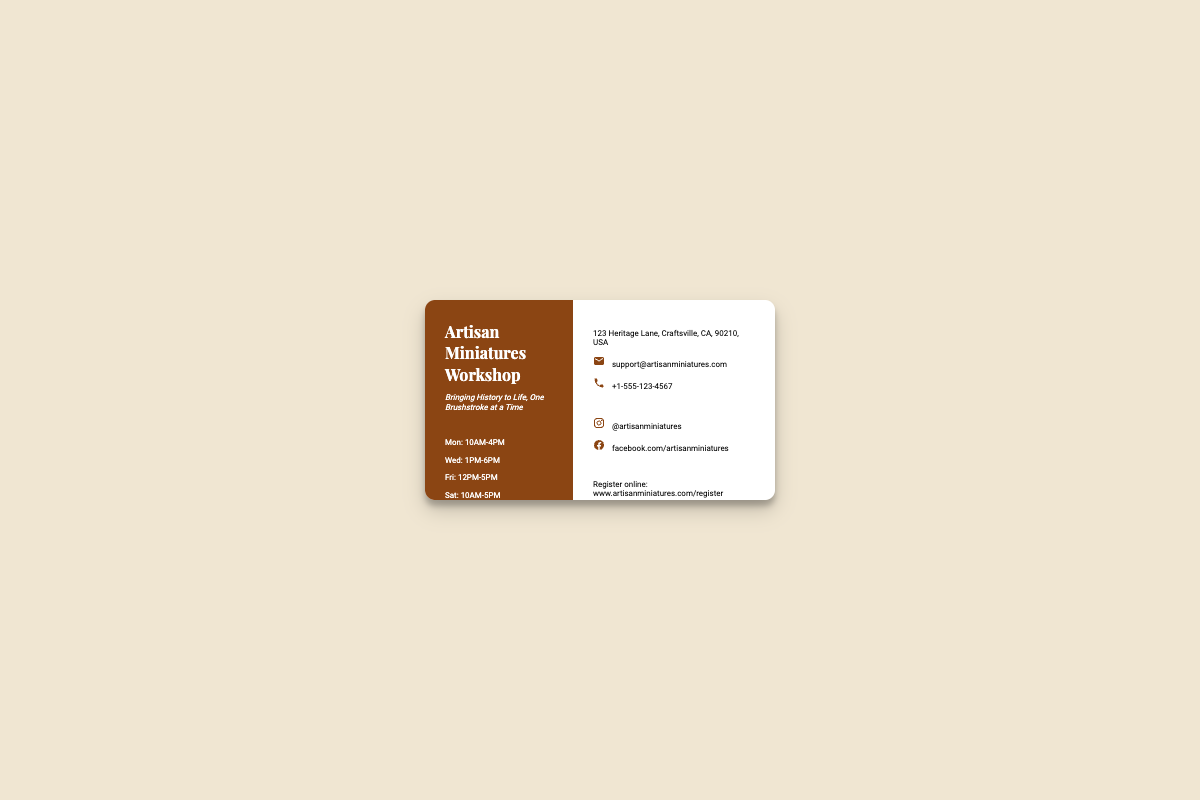What are the workshop hours on Monday? The workshop hours on Monday are specifically listed in the schedule section of the document.
Answer: 10AM-4PM What is the address of the Artisan Miniatures Workshop? The address is provided in the contact section of the document.
Answer: 123 Heritage Lane, Craftsville, CA, 90210, USA What is the registration website? The registration website is mentioned in the registration section of the document.
Answer: www.artisanminiatures.com/register What is the tagline for the workshop? The tagline is a slogan present under the workshop name in the left section of the card.
Answer: Bringing History to Life, One Brushstroke at a Time How many days a week is the workshop open? This can be calculated by counting the days listed in the schedule section of the document.
Answer: 4 days What email address can be used for support? The support email is given in the contact section of the document.
Answer: support@artisanminiatures.com What is the phone number for Artisan Miniatures? The phone number appears in the contact section and is easily identifiable.
Answer: +1-555-123-4567 On which day does the workshop close the latest? This requires comparing the closing times across all days in the schedule.
Answer: Wednesday What percentage of the business card is occupied by the left side? The left side is specified as 40% of the total width of the business card.
Answer: 40% 